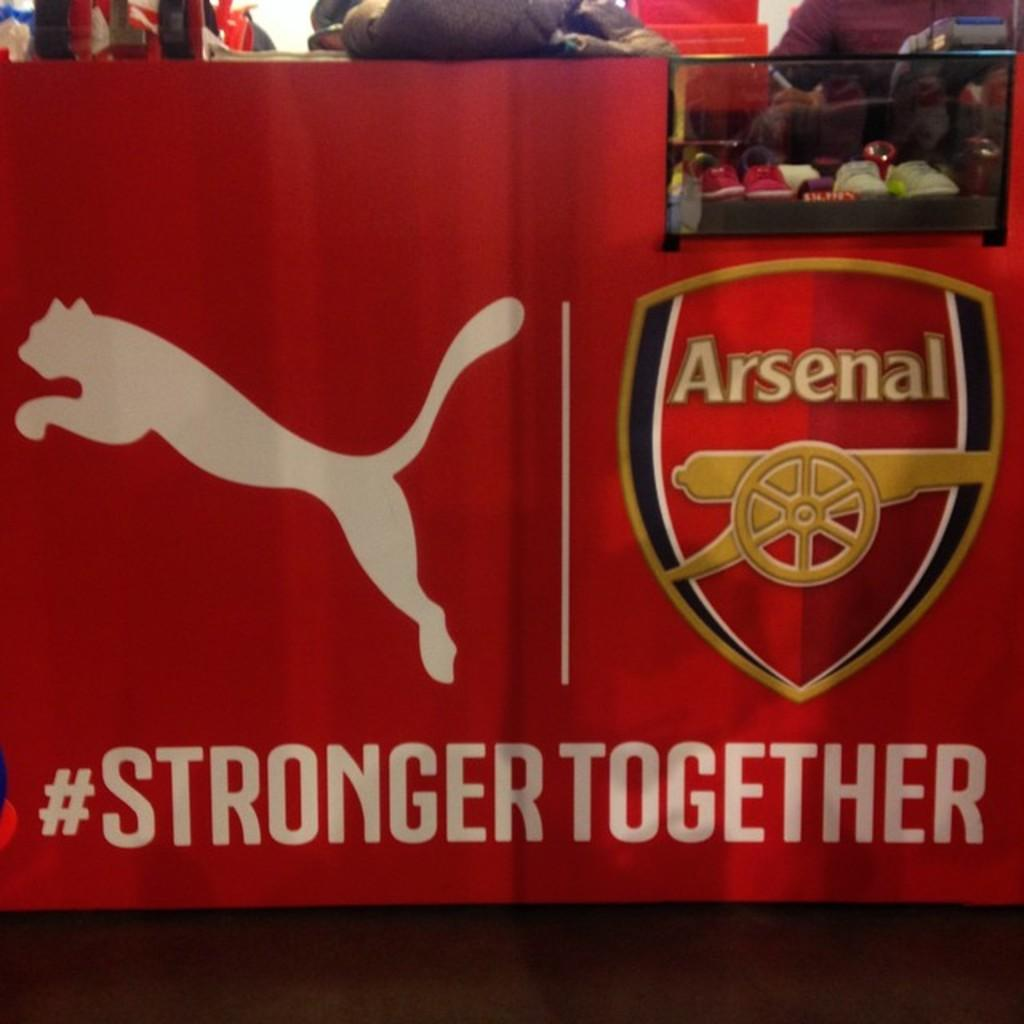<image>
Write a terse but informative summary of the picture. A red ad for arsenal with a puma on the left and the hash tag stronger together on the bottom. 